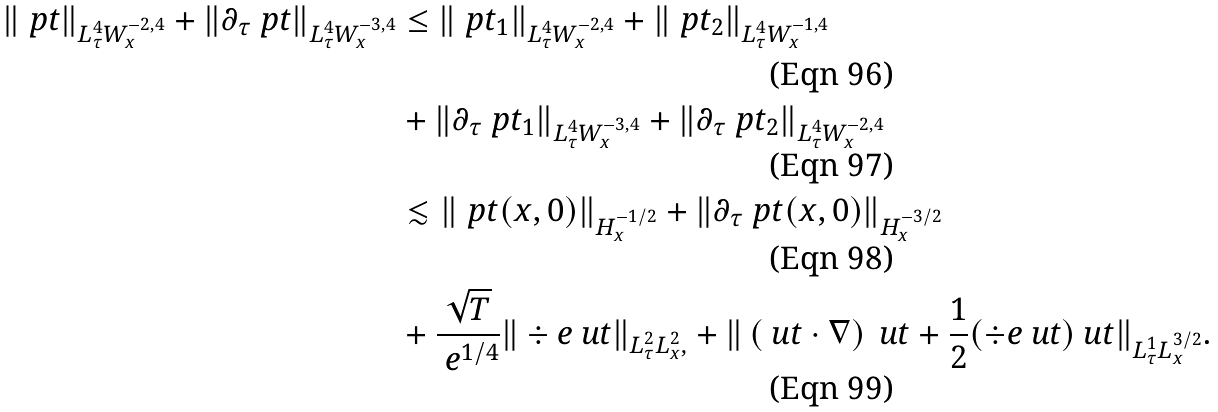Convert formula to latex. <formula><loc_0><loc_0><loc_500><loc_500>\| \ p t \| _ { L ^ { 4 } _ { \tau } W ^ { - 2 , 4 } _ { x } } + \| \partial _ { \tau } \ p t \| _ { L ^ { 4 } _ { \tau } W ^ { - 3 , 4 } _ { x } } & \leq \| \ p t _ { 1 } \| _ { L ^ { 4 } _ { \tau } W ^ { - 2 , 4 } _ { x } } + \| \ p t _ { 2 } \| _ { L ^ { 4 } _ { \tau } W ^ { - 1 , 4 } _ { x } } \\ & + \| \partial _ { \tau } \ p t _ { 1 } \| _ { L ^ { 4 } _ { \tau } W ^ { - 3 , 4 } _ { x } } + \| \partial _ { \tau } \ p t _ { 2 } \| _ { L ^ { 4 } _ { \tau } W ^ { - 2 , 4 } _ { x } } \\ & \lesssim \| \ p t ( x , 0 ) \| _ { H ^ { - 1 / 2 } _ { x } } + \| \partial _ { \tau } \ p t ( x , 0 ) \| _ { H ^ { - 3 / 2 } _ { x } } \\ & + \frac { \sqrt { T } } { \ e ^ { 1 / 4 } } \| \div e \ u t \| _ { L ^ { 2 } _ { \tau } L ^ { 2 } _ { x } , } + \| \left ( \ u t \cdot \nabla \right ) \ u t + \frac { 1 } { 2 } ( \div e \ u t ) \ u t \| _ { L ^ { 1 } _ { \tau } L ^ { 3 / 2 } _ { x } } .</formula> 